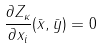<formula> <loc_0><loc_0><loc_500><loc_500>\frac { \partial Z _ { \kappa } } { \partial x _ { i } } ( \bar { x } , \bar { y } ) = 0</formula> 